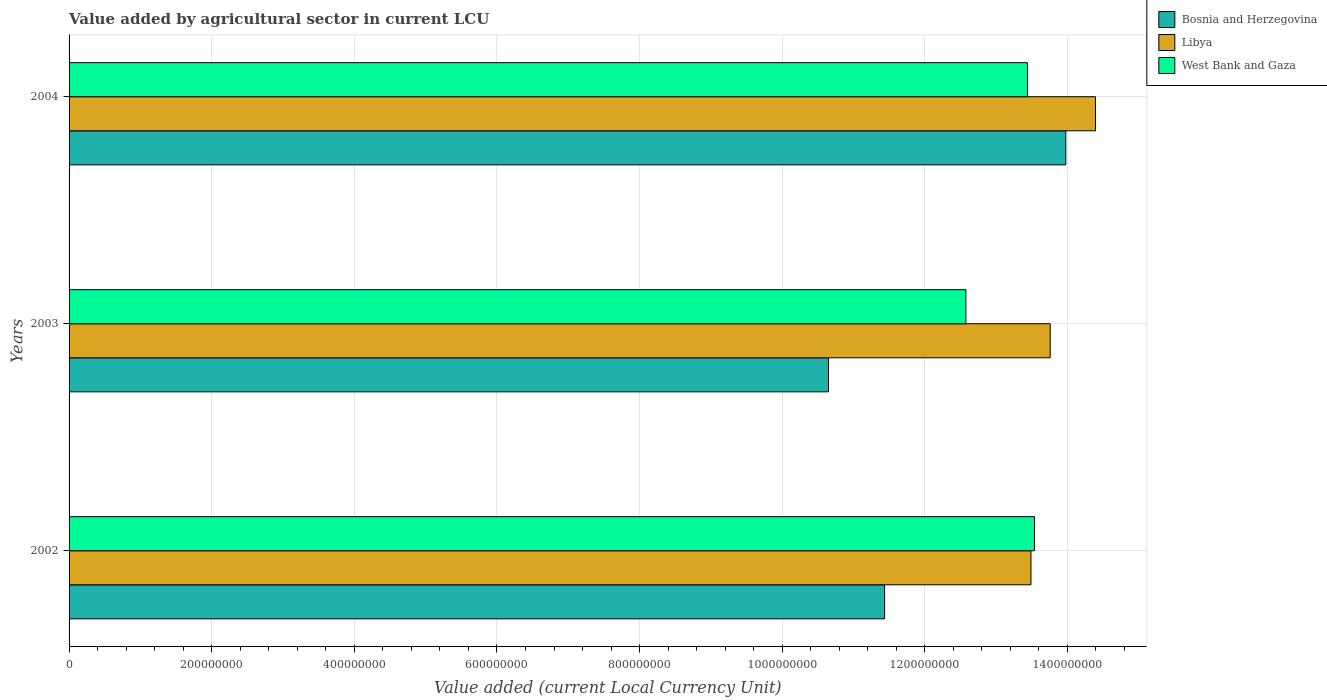How many different coloured bars are there?
Offer a very short reply. 3. Are the number of bars per tick equal to the number of legend labels?
Offer a very short reply. Yes. Are the number of bars on each tick of the Y-axis equal?
Give a very brief answer. Yes. How many bars are there on the 2nd tick from the top?
Provide a short and direct response. 3. How many bars are there on the 1st tick from the bottom?
Make the answer very short. 3. In how many cases, is the number of bars for a given year not equal to the number of legend labels?
Your answer should be very brief. 0. What is the value added by agricultural sector in Bosnia and Herzegovina in 2003?
Offer a terse response. 1.06e+09. Across all years, what is the maximum value added by agricultural sector in West Bank and Gaza?
Ensure brevity in your answer.  1.35e+09. Across all years, what is the minimum value added by agricultural sector in Bosnia and Herzegovina?
Your answer should be compact. 1.06e+09. In which year was the value added by agricultural sector in Bosnia and Herzegovina maximum?
Provide a succinct answer. 2004. In which year was the value added by agricultural sector in Bosnia and Herzegovina minimum?
Make the answer very short. 2003. What is the total value added by agricultural sector in Bosnia and Herzegovina in the graph?
Provide a succinct answer. 3.61e+09. What is the difference between the value added by agricultural sector in West Bank and Gaza in 2002 and that in 2004?
Your answer should be very brief. 9.74e+06. What is the difference between the value added by agricultural sector in West Bank and Gaza in 2003 and the value added by agricultural sector in Libya in 2002?
Give a very brief answer. -9.12e+07. What is the average value added by agricultural sector in West Bank and Gaza per year?
Ensure brevity in your answer.  1.32e+09. In the year 2003, what is the difference between the value added by agricultural sector in Bosnia and Herzegovina and value added by agricultural sector in West Bank and Gaza?
Ensure brevity in your answer.  -1.93e+08. In how many years, is the value added by agricultural sector in West Bank and Gaza greater than 1440000000 LCU?
Provide a succinct answer. 0. What is the ratio of the value added by agricultural sector in Libya in 2002 to that in 2004?
Offer a very short reply. 0.94. What is the difference between the highest and the second highest value added by agricultural sector in Bosnia and Herzegovina?
Provide a short and direct response. 2.54e+08. What is the difference between the highest and the lowest value added by agricultural sector in Bosnia and Herzegovina?
Make the answer very short. 3.33e+08. What does the 1st bar from the top in 2004 represents?
Keep it short and to the point. West Bank and Gaza. What does the 2nd bar from the bottom in 2004 represents?
Keep it short and to the point. Libya. Is it the case that in every year, the sum of the value added by agricultural sector in Libya and value added by agricultural sector in West Bank and Gaza is greater than the value added by agricultural sector in Bosnia and Herzegovina?
Offer a very short reply. Yes. How many bars are there?
Your response must be concise. 9. Are all the bars in the graph horizontal?
Your response must be concise. Yes. What is the difference between two consecutive major ticks on the X-axis?
Your answer should be very brief. 2.00e+08. Are the values on the major ticks of X-axis written in scientific E-notation?
Your response must be concise. No. Where does the legend appear in the graph?
Ensure brevity in your answer.  Top right. What is the title of the graph?
Your response must be concise. Value added by agricultural sector in current LCU. Does "Tajikistan" appear as one of the legend labels in the graph?
Give a very brief answer. No. What is the label or title of the X-axis?
Provide a succinct answer. Value added (current Local Currency Unit). What is the label or title of the Y-axis?
Your answer should be compact. Years. What is the Value added (current Local Currency Unit) in Bosnia and Herzegovina in 2002?
Your response must be concise. 1.14e+09. What is the Value added (current Local Currency Unit) in Libya in 2002?
Make the answer very short. 1.35e+09. What is the Value added (current Local Currency Unit) of West Bank and Gaza in 2002?
Your answer should be very brief. 1.35e+09. What is the Value added (current Local Currency Unit) in Bosnia and Herzegovina in 2003?
Your response must be concise. 1.06e+09. What is the Value added (current Local Currency Unit) of Libya in 2003?
Offer a terse response. 1.38e+09. What is the Value added (current Local Currency Unit) of West Bank and Gaza in 2003?
Your answer should be compact. 1.26e+09. What is the Value added (current Local Currency Unit) in Bosnia and Herzegovina in 2004?
Give a very brief answer. 1.40e+09. What is the Value added (current Local Currency Unit) of Libya in 2004?
Offer a very short reply. 1.44e+09. What is the Value added (current Local Currency Unit) in West Bank and Gaza in 2004?
Ensure brevity in your answer.  1.34e+09. Across all years, what is the maximum Value added (current Local Currency Unit) of Bosnia and Herzegovina?
Make the answer very short. 1.40e+09. Across all years, what is the maximum Value added (current Local Currency Unit) of Libya?
Your response must be concise. 1.44e+09. Across all years, what is the maximum Value added (current Local Currency Unit) in West Bank and Gaza?
Your answer should be very brief. 1.35e+09. Across all years, what is the minimum Value added (current Local Currency Unit) of Bosnia and Herzegovina?
Give a very brief answer. 1.06e+09. Across all years, what is the minimum Value added (current Local Currency Unit) in Libya?
Provide a short and direct response. 1.35e+09. Across all years, what is the minimum Value added (current Local Currency Unit) of West Bank and Gaza?
Give a very brief answer. 1.26e+09. What is the total Value added (current Local Currency Unit) of Bosnia and Herzegovina in the graph?
Provide a succinct answer. 3.61e+09. What is the total Value added (current Local Currency Unit) of Libya in the graph?
Your answer should be compact. 4.16e+09. What is the total Value added (current Local Currency Unit) of West Bank and Gaza in the graph?
Your answer should be very brief. 3.96e+09. What is the difference between the Value added (current Local Currency Unit) of Bosnia and Herzegovina in 2002 and that in 2003?
Offer a terse response. 7.87e+07. What is the difference between the Value added (current Local Currency Unit) in Libya in 2002 and that in 2003?
Provide a succinct answer. -2.70e+07. What is the difference between the Value added (current Local Currency Unit) in West Bank and Gaza in 2002 and that in 2003?
Your answer should be compact. 9.62e+07. What is the difference between the Value added (current Local Currency Unit) in Bosnia and Herzegovina in 2002 and that in 2004?
Offer a terse response. -2.54e+08. What is the difference between the Value added (current Local Currency Unit) in Libya in 2002 and that in 2004?
Provide a short and direct response. -9.05e+07. What is the difference between the Value added (current Local Currency Unit) of West Bank and Gaza in 2002 and that in 2004?
Your answer should be compact. 9.74e+06. What is the difference between the Value added (current Local Currency Unit) of Bosnia and Herzegovina in 2003 and that in 2004?
Your response must be concise. -3.33e+08. What is the difference between the Value added (current Local Currency Unit) in Libya in 2003 and that in 2004?
Ensure brevity in your answer.  -6.35e+07. What is the difference between the Value added (current Local Currency Unit) in West Bank and Gaza in 2003 and that in 2004?
Offer a very short reply. -8.64e+07. What is the difference between the Value added (current Local Currency Unit) of Bosnia and Herzegovina in 2002 and the Value added (current Local Currency Unit) of Libya in 2003?
Your answer should be very brief. -2.32e+08. What is the difference between the Value added (current Local Currency Unit) in Bosnia and Herzegovina in 2002 and the Value added (current Local Currency Unit) in West Bank and Gaza in 2003?
Provide a short and direct response. -1.14e+08. What is the difference between the Value added (current Local Currency Unit) of Libya in 2002 and the Value added (current Local Currency Unit) of West Bank and Gaza in 2003?
Your answer should be compact. 9.12e+07. What is the difference between the Value added (current Local Currency Unit) of Bosnia and Herzegovina in 2002 and the Value added (current Local Currency Unit) of Libya in 2004?
Your answer should be compact. -2.96e+08. What is the difference between the Value added (current Local Currency Unit) in Bosnia and Herzegovina in 2002 and the Value added (current Local Currency Unit) in West Bank and Gaza in 2004?
Provide a succinct answer. -2.00e+08. What is the difference between the Value added (current Local Currency Unit) of Libya in 2002 and the Value added (current Local Currency Unit) of West Bank and Gaza in 2004?
Make the answer very short. 4.80e+06. What is the difference between the Value added (current Local Currency Unit) of Bosnia and Herzegovina in 2003 and the Value added (current Local Currency Unit) of Libya in 2004?
Give a very brief answer. -3.74e+08. What is the difference between the Value added (current Local Currency Unit) in Bosnia and Herzegovina in 2003 and the Value added (current Local Currency Unit) in West Bank and Gaza in 2004?
Ensure brevity in your answer.  -2.79e+08. What is the difference between the Value added (current Local Currency Unit) of Libya in 2003 and the Value added (current Local Currency Unit) of West Bank and Gaza in 2004?
Offer a very short reply. 3.18e+07. What is the average Value added (current Local Currency Unit) of Bosnia and Herzegovina per year?
Ensure brevity in your answer.  1.20e+09. What is the average Value added (current Local Currency Unit) of Libya per year?
Provide a succinct answer. 1.39e+09. What is the average Value added (current Local Currency Unit) in West Bank and Gaza per year?
Make the answer very short. 1.32e+09. In the year 2002, what is the difference between the Value added (current Local Currency Unit) of Bosnia and Herzegovina and Value added (current Local Currency Unit) of Libya?
Your answer should be compact. -2.05e+08. In the year 2002, what is the difference between the Value added (current Local Currency Unit) of Bosnia and Herzegovina and Value added (current Local Currency Unit) of West Bank and Gaza?
Offer a very short reply. -2.10e+08. In the year 2002, what is the difference between the Value added (current Local Currency Unit) in Libya and Value added (current Local Currency Unit) in West Bank and Gaza?
Provide a short and direct response. -4.94e+06. In the year 2003, what is the difference between the Value added (current Local Currency Unit) of Bosnia and Herzegovina and Value added (current Local Currency Unit) of Libya?
Give a very brief answer. -3.11e+08. In the year 2003, what is the difference between the Value added (current Local Currency Unit) of Bosnia and Herzegovina and Value added (current Local Currency Unit) of West Bank and Gaza?
Provide a short and direct response. -1.93e+08. In the year 2003, what is the difference between the Value added (current Local Currency Unit) of Libya and Value added (current Local Currency Unit) of West Bank and Gaza?
Keep it short and to the point. 1.18e+08. In the year 2004, what is the difference between the Value added (current Local Currency Unit) of Bosnia and Herzegovina and Value added (current Local Currency Unit) of Libya?
Your answer should be very brief. -4.17e+07. In the year 2004, what is the difference between the Value added (current Local Currency Unit) of Bosnia and Herzegovina and Value added (current Local Currency Unit) of West Bank and Gaza?
Give a very brief answer. 5.36e+07. In the year 2004, what is the difference between the Value added (current Local Currency Unit) of Libya and Value added (current Local Currency Unit) of West Bank and Gaza?
Offer a very short reply. 9.53e+07. What is the ratio of the Value added (current Local Currency Unit) in Bosnia and Herzegovina in 2002 to that in 2003?
Offer a very short reply. 1.07. What is the ratio of the Value added (current Local Currency Unit) in Libya in 2002 to that in 2003?
Provide a short and direct response. 0.98. What is the ratio of the Value added (current Local Currency Unit) of West Bank and Gaza in 2002 to that in 2003?
Make the answer very short. 1.08. What is the ratio of the Value added (current Local Currency Unit) in Bosnia and Herzegovina in 2002 to that in 2004?
Make the answer very short. 0.82. What is the ratio of the Value added (current Local Currency Unit) in Libya in 2002 to that in 2004?
Make the answer very short. 0.94. What is the ratio of the Value added (current Local Currency Unit) of Bosnia and Herzegovina in 2003 to that in 2004?
Provide a succinct answer. 0.76. What is the ratio of the Value added (current Local Currency Unit) in Libya in 2003 to that in 2004?
Provide a succinct answer. 0.96. What is the ratio of the Value added (current Local Currency Unit) of West Bank and Gaza in 2003 to that in 2004?
Keep it short and to the point. 0.94. What is the difference between the highest and the second highest Value added (current Local Currency Unit) in Bosnia and Herzegovina?
Offer a terse response. 2.54e+08. What is the difference between the highest and the second highest Value added (current Local Currency Unit) of Libya?
Keep it short and to the point. 6.35e+07. What is the difference between the highest and the second highest Value added (current Local Currency Unit) of West Bank and Gaza?
Offer a terse response. 9.74e+06. What is the difference between the highest and the lowest Value added (current Local Currency Unit) in Bosnia and Herzegovina?
Provide a succinct answer. 3.33e+08. What is the difference between the highest and the lowest Value added (current Local Currency Unit) in Libya?
Your response must be concise. 9.05e+07. What is the difference between the highest and the lowest Value added (current Local Currency Unit) in West Bank and Gaza?
Your response must be concise. 9.62e+07. 